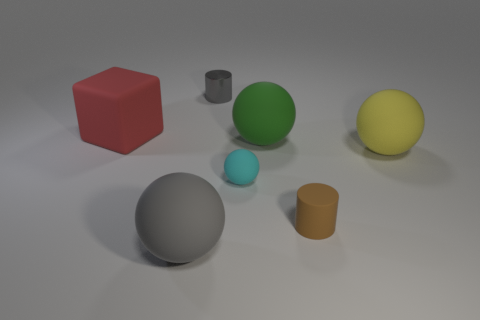Subtract 1 balls. How many balls are left? 3 Subtract all green balls. How many balls are left? 3 Subtract all purple balls. Subtract all purple blocks. How many balls are left? 4 Add 2 yellow balls. How many objects exist? 9 Subtract all cubes. How many objects are left? 6 Add 7 small objects. How many small objects exist? 10 Subtract 0 blue cubes. How many objects are left? 7 Subtract all green metallic things. Subtract all small cylinders. How many objects are left? 5 Add 6 cyan rubber spheres. How many cyan rubber spheres are left? 7 